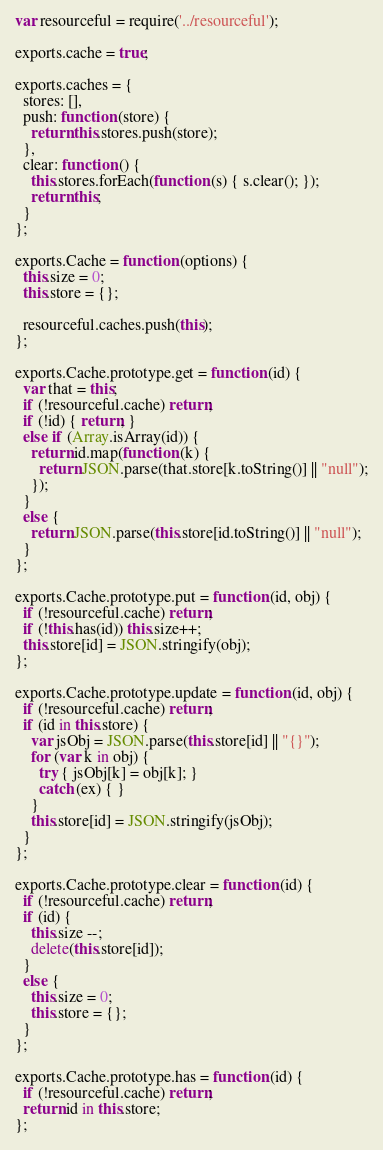<code> <loc_0><loc_0><loc_500><loc_500><_JavaScript_>var resourceful = require('../resourceful');

exports.cache = true;

exports.caches = {
  stores: [],
  push: function (store) {
    return this.stores.push(store);
  },
  clear: function () {
    this.stores.forEach(function (s) { s.clear(); });
    return this;
  }
};

exports.Cache = function (options) {
  this.size = 0;
  this.store = {};

  resourceful.caches.push(this);
};

exports.Cache.prototype.get = function (id) {
  var that = this;
  if (!resourceful.cache) return;
  if (!id) { return; }
  else if (Array.isArray(id)) {
    return id.map(function (k) {
      return JSON.parse(that.store[k.toString()] || "null");
    });
  }
  else {
    return JSON.parse(this.store[id.toString()] || "null");
  }
};

exports.Cache.prototype.put = function (id, obj) {
  if (!resourceful.cache) return;
  if (!this.has(id)) this.size++;
  this.store[id] = JSON.stringify(obj);
};

exports.Cache.prototype.update = function (id, obj) {
  if (!resourceful.cache) return;
  if (id in this.store) {
    var jsObj = JSON.parse(this.store[id] || "{}");
    for (var k in obj) {
      try { jsObj[k] = obj[k]; }
      catch (ex) { }
    }
    this.store[id] = JSON.stringify(jsObj);
  }
};

exports.Cache.prototype.clear = function (id) {
  if (!resourceful.cache) return;
  if (id) {
    this.size --;
    delete(this.store[id]);
  }
  else {
    this.size = 0;
    this.store = {};
  }
};

exports.Cache.prototype.has = function (id) {
  if (!resourceful.cache) return;
  return id in this.store;
};
</code> 